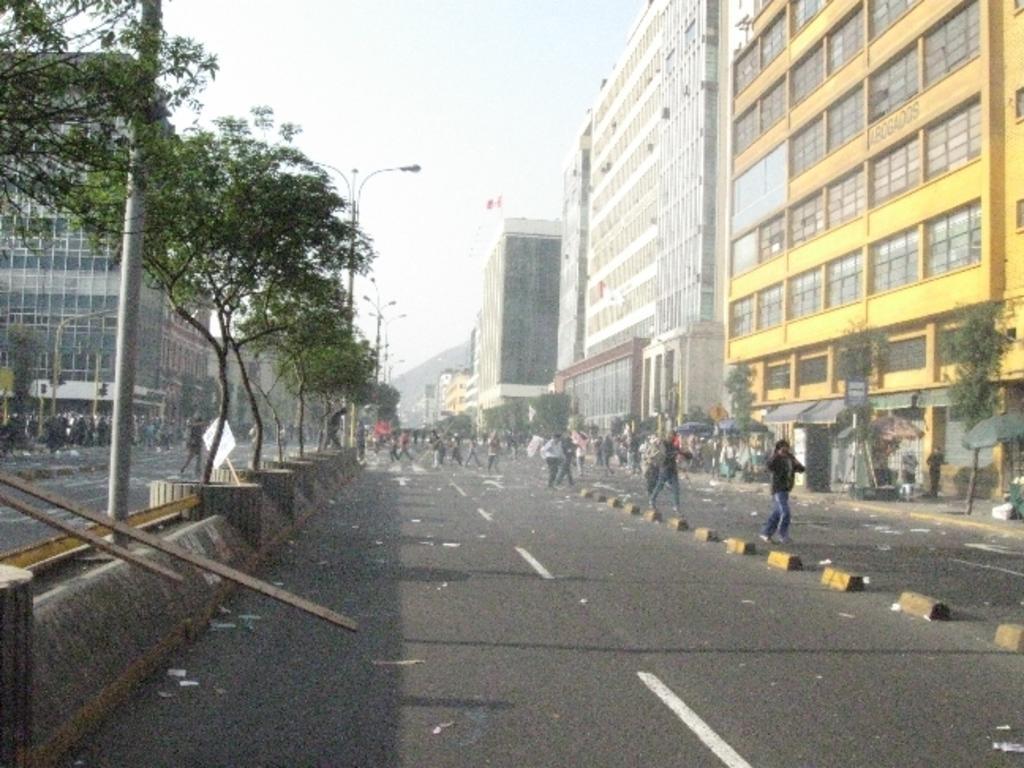How would you summarize this image in a sentence or two? This picture describes about group of people, in the background we can see few poles, lights, buildings and trees. 